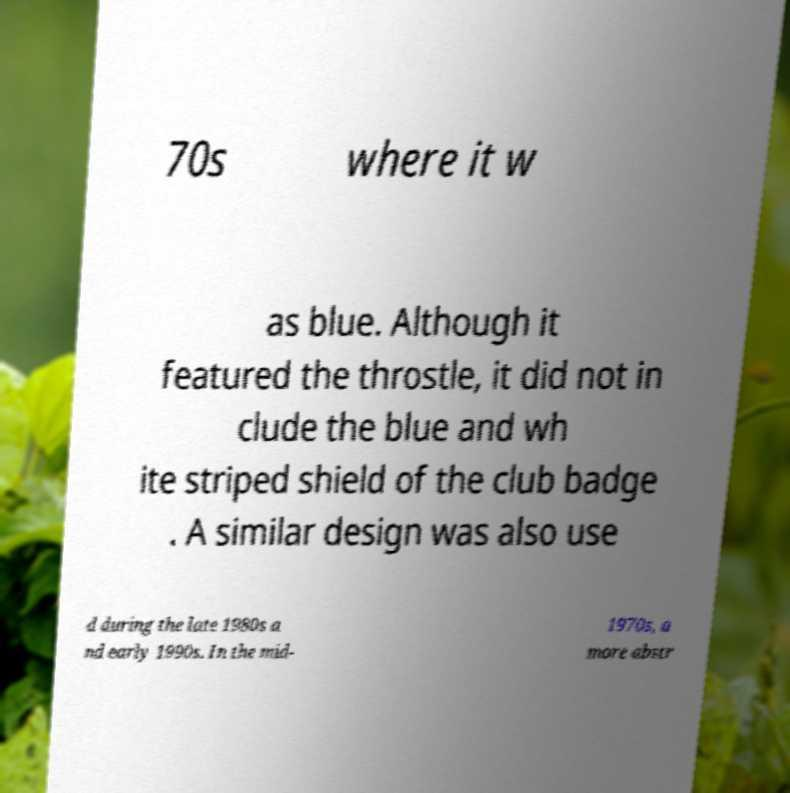Could you assist in decoding the text presented in this image and type it out clearly? 70s where it w as blue. Although it featured the throstle, it did not in clude the blue and wh ite striped shield of the club badge . A similar design was also use d during the late 1980s a nd early 1990s. In the mid- 1970s, a more abstr 